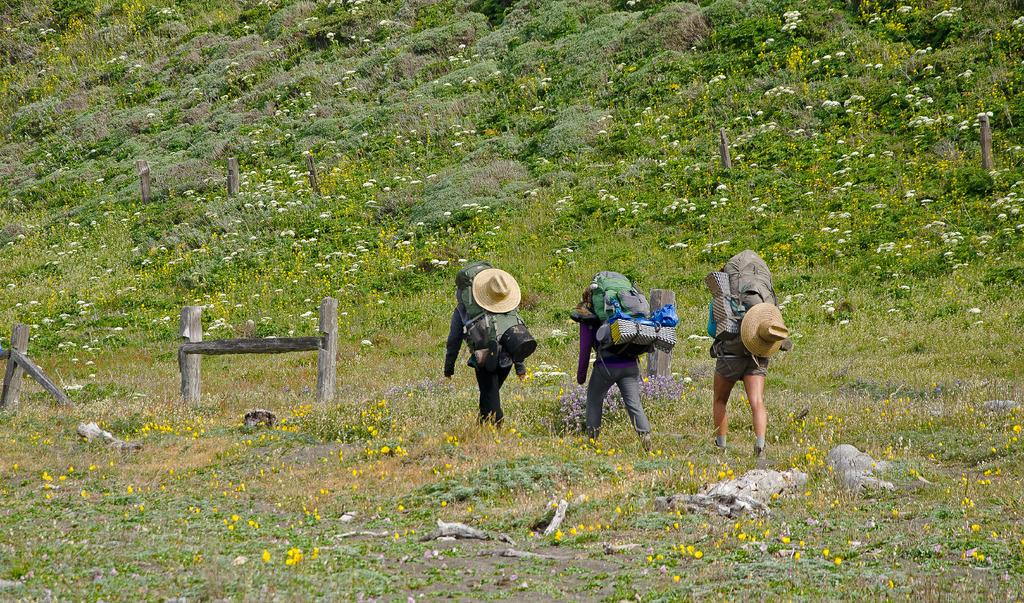What is the setting of the image? The image is an outside view. How many people are in the image? There are three persons in the image. What are the persons wearing? The persons are wearing bags. What are the persons doing in the image? The persons are walking on the ground. What type of vegetation can be seen in the image? There are many flower plants in the image. What objects can be seen on the left side of the image? There are wooden sticks on the left side of the image. Reasoning: Let' Let's think step by step in order to produce the conversation. We start by identifying the setting of the image, which is an outside view. Then, we focus on the people in the image, noting their number, actions, and what they are wearing. Next, we describe the vegetation and other objects present in the image. Each question is designed to elicit a specific detail about the image that is known from the provided facts. Absurd Question/Answer: What type of skin condition can be seen on the goat in the image? There is no goat present in the image, so it is not possible to determine any skin conditions. 